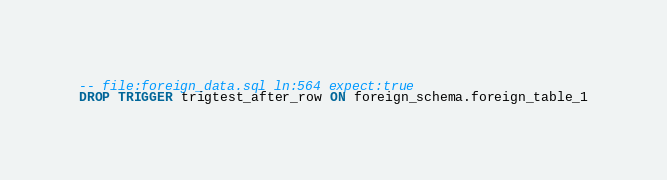<code> <loc_0><loc_0><loc_500><loc_500><_SQL_>-- file:foreign_data.sql ln:564 expect:true
DROP TRIGGER trigtest_after_row ON foreign_schema.foreign_table_1
</code> 